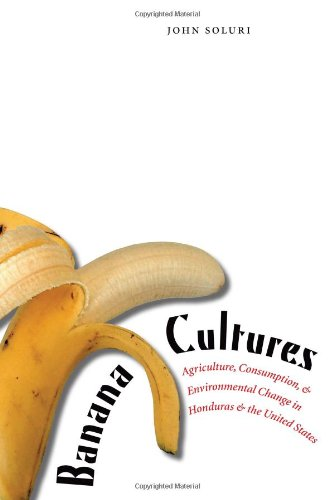What is the title of this book? The book is titled 'Banana Cultures: Agriculture, Consumption, and Environmental Change in Honduras and the United States,' exploring the intricate relationships between agriculture, consumption, and environmental policies. 